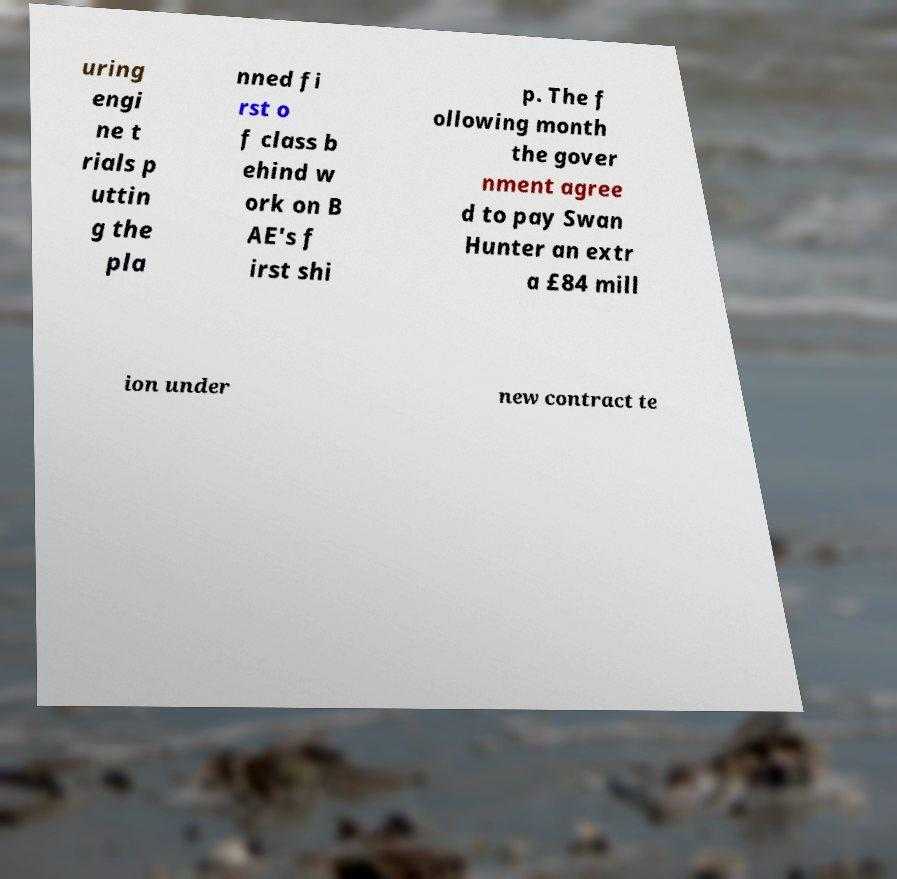Can you read and provide the text displayed in the image?This photo seems to have some interesting text. Can you extract and type it out for me? uring engi ne t rials p uttin g the pla nned fi rst o f class b ehind w ork on B AE's f irst shi p. The f ollowing month the gover nment agree d to pay Swan Hunter an extr a £84 mill ion under new contract te 